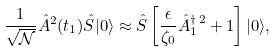Convert formula to latex. <formula><loc_0><loc_0><loc_500><loc_500>\frac { 1 } { \sqrt { \mathcal { N } } } \hat { A } ^ { 2 } ( t _ { 1 } ) \hat { S } | { 0 } \rangle \approx \hat { S } \left [ \frac { \epsilon } { \zeta _ { 0 } } \hat { A } _ { 1 } ^ { \dagger \, 2 } + 1 \right ] | { 0 } \rangle ,</formula> 